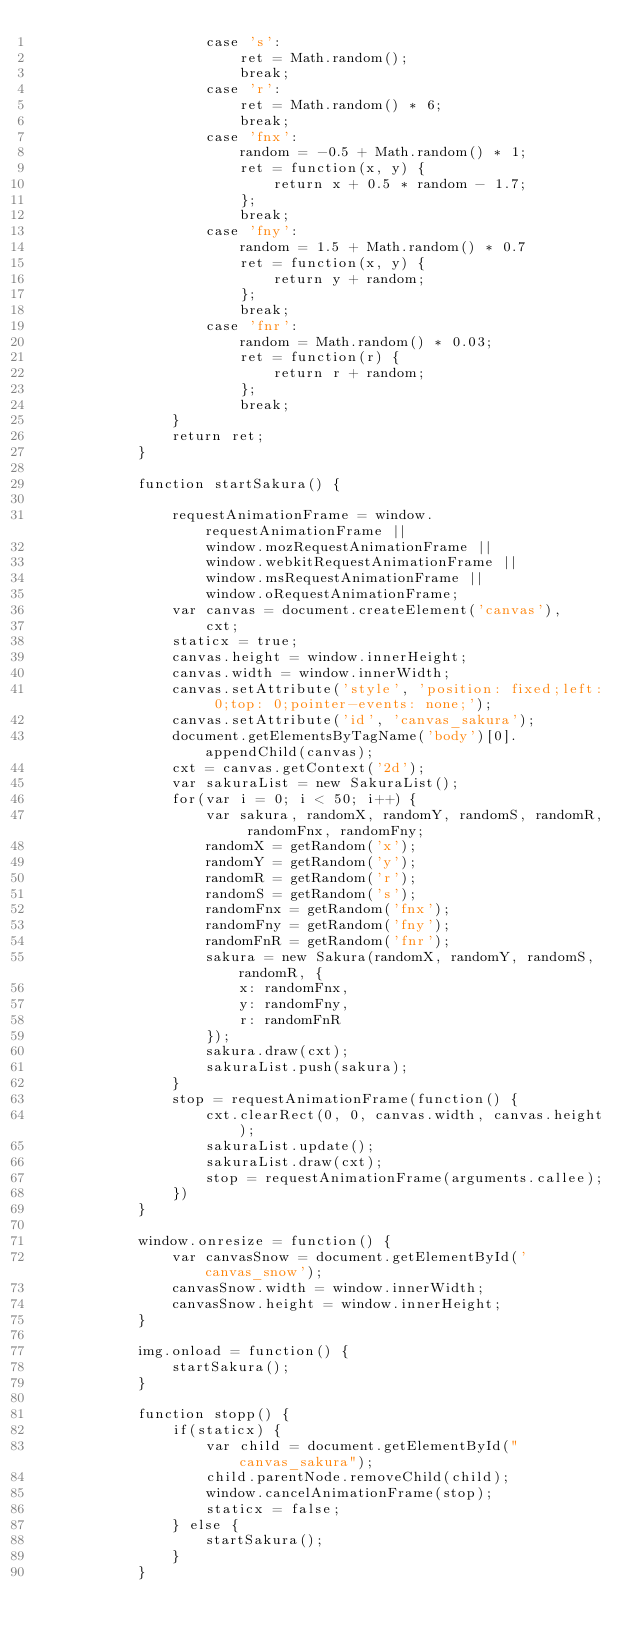Convert code to text. <code><loc_0><loc_0><loc_500><loc_500><_JavaScript_>					case 's':
						ret = Math.random();
						break;
					case 'r':
						ret = Math.random() * 6;
						break;
					case 'fnx':
						random = -0.5 + Math.random() * 1;
						ret = function(x, y) {
							return x + 0.5 * random - 1.7;
						};
						break;
					case 'fny':
						random = 1.5 + Math.random() * 0.7
						ret = function(x, y) {
							return y + random;
						};
						break;
					case 'fnr':
						random = Math.random() * 0.03;
						ret = function(r) {
							return r + random;
						};
						break;
				}
				return ret;
			}

			function startSakura() {

				requestAnimationFrame = window.requestAnimationFrame ||
					window.mozRequestAnimationFrame ||
					window.webkitRequestAnimationFrame ||
					window.msRequestAnimationFrame ||
					window.oRequestAnimationFrame;
				var canvas = document.createElement('canvas'),
					cxt;
				staticx = true;
				canvas.height = window.innerHeight;
				canvas.width = window.innerWidth;
				canvas.setAttribute('style', 'position: fixed;left: 0;top: 0;pointer-events: none;');
				canvas.setAttribute('id', 'canvas_sakura');
				document.getElementsByTagName('body')[0].appendChild(canvas);
				cxt = canvas.getContext('2d');
				var sakuraList = new SakuraList();
				for(var i = 0; i < 50; i++) {
					var sakura, randomX, randomY, randomS, randomR, randomFnx, randomFny;
					randomX = getRandom('x');
					randomY = getRandom('y');
					randomR = getRandom('r');
					randomS = getRandom('s');
					randomFnx = getRandom('fnx');
					randomFny = getRandom('fny');
					randomFnR = getRandom('fnr');
					sakura = new Sakura(randomX, randomY, randomS, randomR, {
						x: randomFnx,
						y: randomFny,
						r: randomFnR
					});
					sakura.draw(cxt);
					sakuraList.push(sakura);
				}
				stop = requestAnimationFrame(function() {
					cxt.clearRect(0, 0, canvas.width, canvas.height);
					sakuraList.update();
					sakuraList.draw(cxt);
					stop = requestAnimationFrame(arguments.callee);
				})
			}

			window.onresize = function() {
				var canvasSnow = document.getElementById('canvas_snow');
				canvasSnow.width = window.innerWidth;
				canvasSnow.height = window.innerHeight;
			}

			img.onload = function() {
				startSakura();
			}

			function stopp() {
				if(staticx) {
					var child = document.getElementById("canvas_sakura");
					child.parentNode.removeChild(child);
					window.cancelAnimationFrame(stop);
					staticx = false;
				} else {
					startSakura();
				}
			}
		
		
</code> 